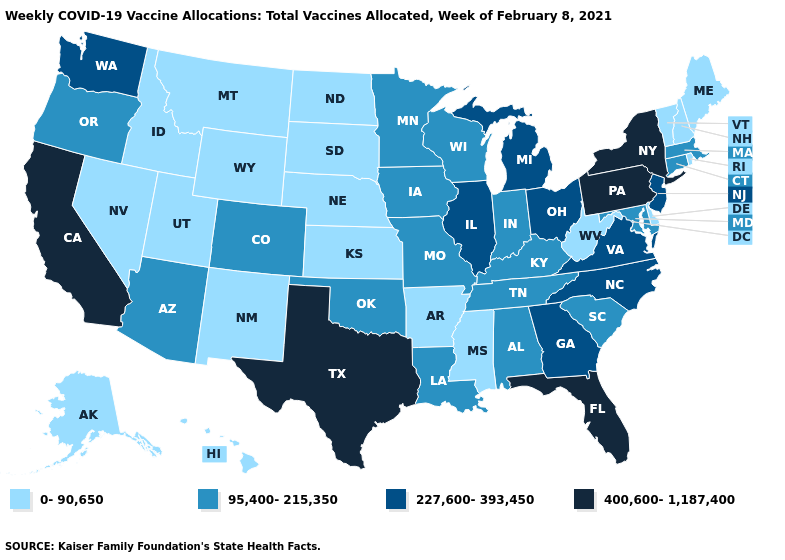Name the states that have a value in the range 0-90,650?
Keep it brief. Alaska, Arkansas, Delaware, Hawaii, Idaho, Kansas, Maine, Mississippi, Montana, Nebraska, Nevada, New Hampshire, New Mexico, North Dakota, Rhode Island, South Dakota, Utah, Vermont, West Virginia, Wyoming. Is the legend a continuous bar?
Answer briefly. No. What is the value of West Virginia?
Give a very brief answer. 0-90,650. Among the states that border California , which have the highest value?
Write a very short answer. Arizona, Oregon. What is the highest value in states that border South Carolina?
Short answer required. 227,600-393,450. Does the first symbol in the legend represent the smallest category?
Keep it brief. Yes. Among the states that border Louisiana , which have the highest value?
Give a very brief answer. Texas. Among the states that border Arkansas , which have the highest value?
Short answer required. Texas. Which states hav the highest value in the MidWest?
Be succinct. Illinois, Michigan, Ohio. Among the states that border Massachusetts , does New York have the highest value?
Quick response, please. Yes. What is the value of North Carolina?
Give a very brief answer. 227,600-393,450. Among the states that border Colorado , does Utah have the lowest value?
Write a very short answer. Yes. Name the states that have a value in the range 400,600-1,187,400?
Keep it brief. California, Florida, New York, Pennsylvania, Texas. Which states have the highest value in the USA?
Quick response, please. California, Florida, New York, Pennsylvania, Texas. What is the highest value in the USA?
Write a very short answer. 400,600-1,187,400. 